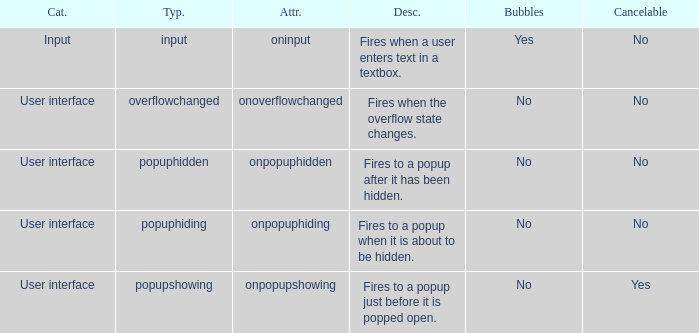What's the type with description being fires when the overflow state changes. Overflowchanged. 